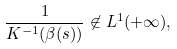<formula> <loc_0><loc_0><loc_500><loc_500>\frac { 1 } { K ^ { - 1 } ( \beta ( s ) ) } \not \in L ^ { 1 } ( + \infty ) ,</formula> 